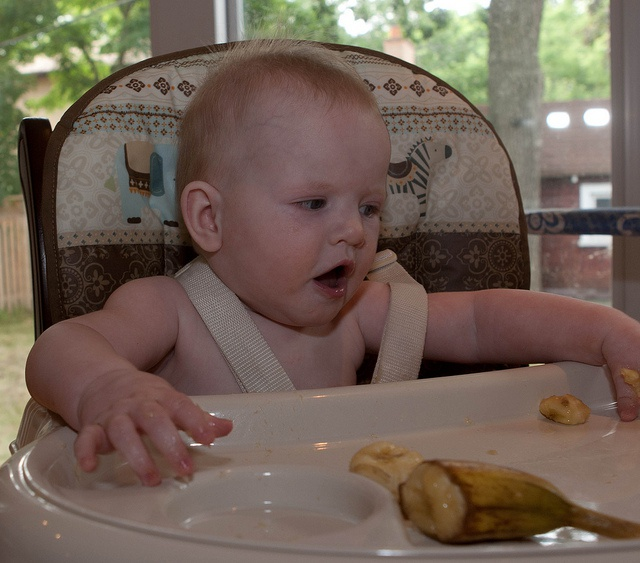Describe the objects in this image and their specific colors. I can see people in olive, brown, maroon, and gray tones, chair in olive, gray, and black tones, and banana in olive, maroon, black, and gray tones in this image. 